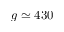Convert formula to latex. <formula><loc_0><loc_0><loc_500><loc_500>g \simeq 4 3 0</formula> 